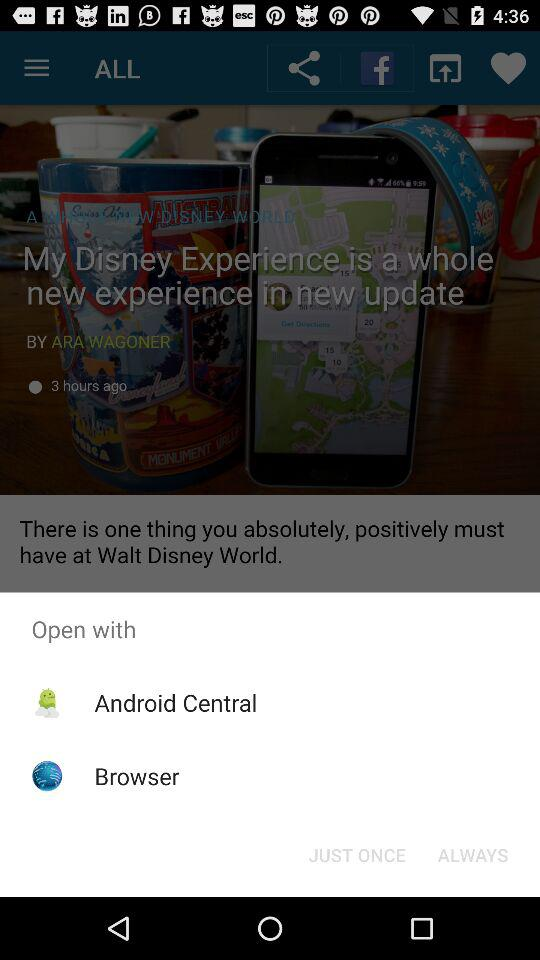Which applications can we use to open? The applications you can use to open are "Android Central" and "Browser". 